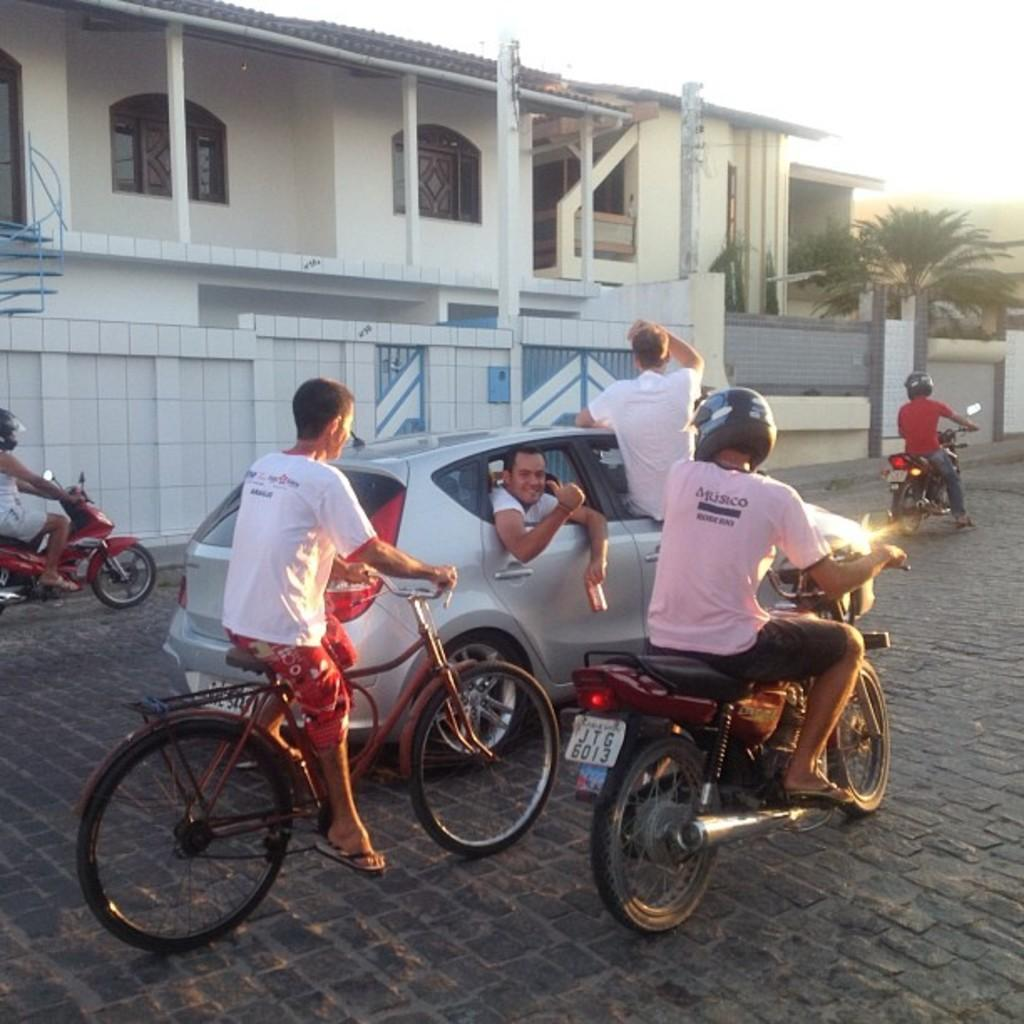What is the primary subject of the image? The primary subject of the image is boys. What are some of the boys doing in the image? Some of the boys are driving a car, while others are on motorcycles and bicycles. Can you describe the position of one of the boys in the image? One boy is sitting on the car's window. What type of smoke can be seen coming from the boat in the image? There is no boat present in the image, so there is no smoke to be observed. 